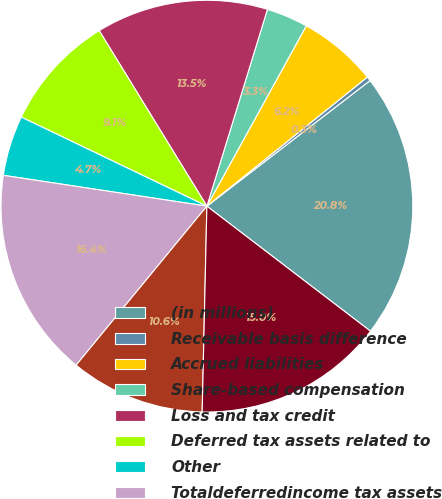<chart> <loc_0><loc_0><loc_500><loc_500><pie_chart><fcel>(in millions)<fcel>Receivable basis difference<fcel>Accrued liabilities<fcel>Share-based compensation<fcel>Loss and tax credit<fcel>Deferred tax assets related to<fcel>Other<fcel>Totaldeferredincome tax assets<fcel>Valuation allowance for<fcel>Net deferredincome tax assets<nl><fcel>20.83%<fcel>0.34%<fcel>6.2%<fcel>3.27%<fcel>13.51%<fcel>9.12%<fcel>4.73%<fcel>16.44%<fcel>10.59%<fcel>14.98%<nl></chart> 